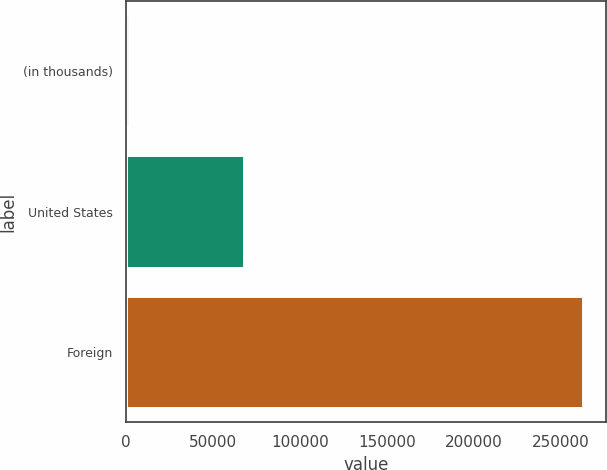<chart> <loc_0><loc_0><loc_500><loc_500><bar_chart><fcel>(in thousands)<fcel>United States<fcel>Foreign<nl><fcel>2012<fcel>67668<fcel>263011<nl></chart> 